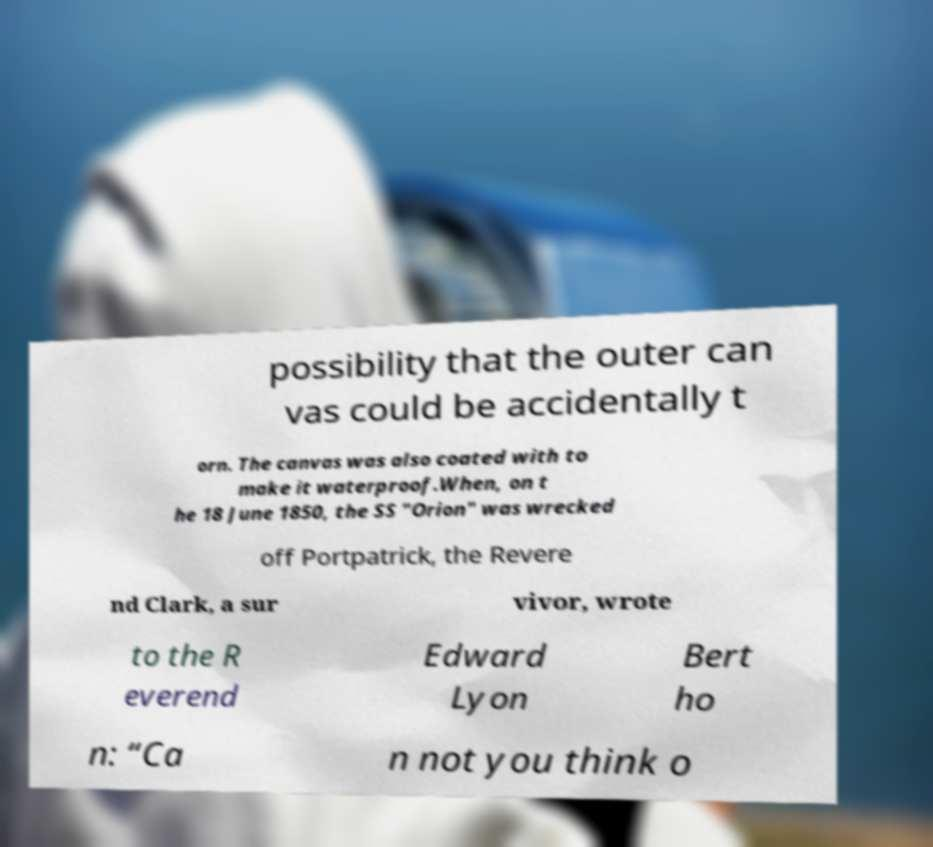There's text embedded in this image that I need extracted. Can you transcribe it verbatim? possibility that the outer can vas could be accidentally t orn. The canvas was also coated with to make it waterproof.When, on t he 18 June 1850, the SS "Orion" was wrecked off Portpatrick, the Revere nd Clark, a sur vivor, wrote to the R everend Edward Lyon Bert ho n: “Ca n not you think o 